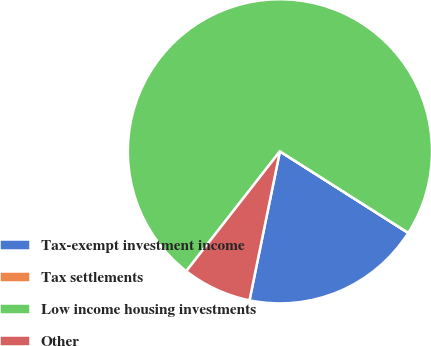Convert chart to OTSL. <chart><loc_0><loc_0><loc_500><loc_500><pie_chart><fcel>Tax-exempt investment income<fcel>Tax settlements<fcel>Low income housing investments<fcel>Other<nl><fcel>19.19%<fcel>0.01%<fcel>73.44%<fcel>7.35%<nl></chart> 